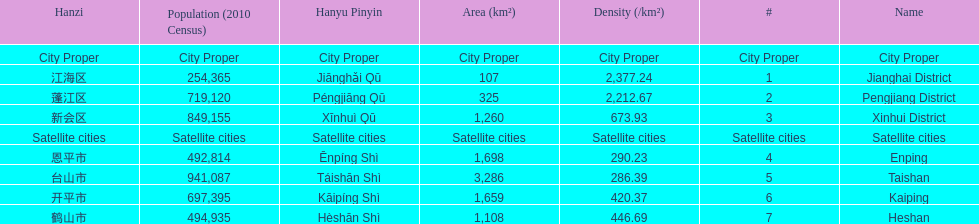What city proper has the smallest area in km2? Jianghai District. 